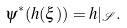Convert formula to latex. <formula><loc_0><loc_0><loc_500><loc_500>\psi ^ { * } ( h ( \xi ) ) = h | _ { \mathcal { S } } .</formula> 